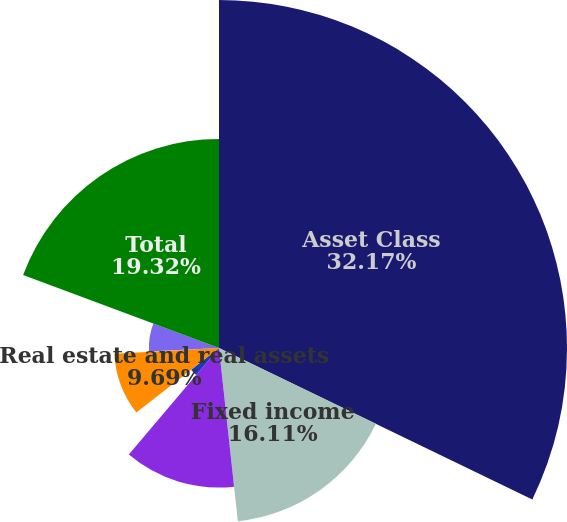Convert chart to OTSL. <chart><loc_0><loc_0><loc_500><loc_500><pie_chart><fcel>Asset Class<fcel>Fixed income<fcel>Global equity<fcel>Private equity<fcel>Real estate and real assets<fcel>Global strategies<fcel>Hedge funds<fcel>Total<nl><fcel>32.16%<fcel>16.11%<fcel>12.9%<fcel>3.27%<fcel>9.69%<fcel>0.06%<fcel>6.48%<fcel>19.32%<nl></chart> 